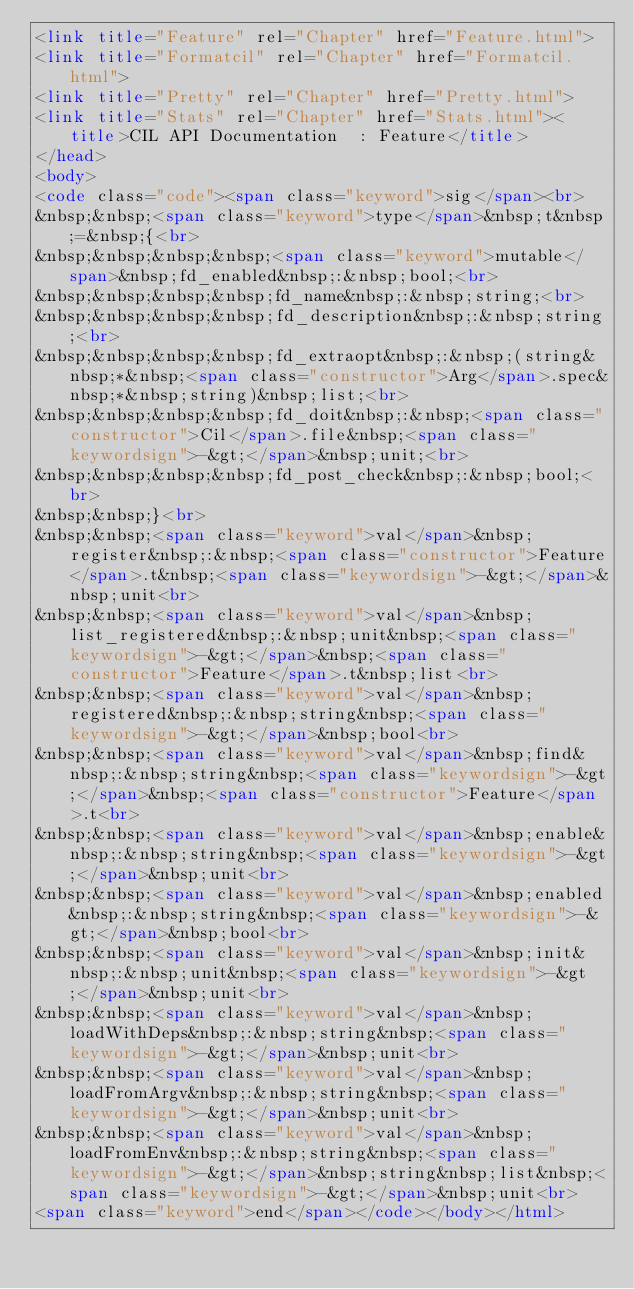Convert code to text. <code><loc_0><loc_0><loc_500><loc_500><_HTML_><link title="Feature" rel="Chapter" href="Feature.html">
<link title="Formatcil" rel="Chapter" href="Formatcil.html">
<link title="Pretty" rel="Chapter" href="Pretty.html">
<link title="Stats" rel="Chapter" href="Stats.html"><title>CIL API Documentation  : Feature</title>
</head>
<body>
<code class="code"><span class="keyword">sig</span><br>
&nbsp;&nbsp;<span class="keyword">type</span>&nbsp;t&nbsp;=&nbsp;{<br>
&nbsp;&nbsp;&nbsp;&nbsp;<span class="keyword">mutable</span>&nbsp;fd_enabled&nbsp;:&nbsp;bool;<br>
&nbsp;&nbsp;&nbsp;&nbsp;fd_name&nbsp;:&nbsp;string;<br>
&nbsp;&nbsp;&nbsp;&nbsp;fd_description&nbsp;:&nbsp;string;<br>
&nbsp;&nbsp;&nbsp;&nbsp;fd_extraopt&nbsp;:&nbsp;(string&nbsp;*&nbsp;<span class="constructor">Arg</span>.spec&nbsp;*&nbsp;string)&nbsp;list;<br>
&nbsp;&nbsp;&nbsp;&nbsp;fd_doit&nbsp;:&nbsp;<span class="constructor">Cil</span>.file&nbsp;<span class="keywordsign">-&gt;</span>&nbsp;unit;<br>
&nbsp;&nbsp;&nbsp;&nbsp;fd_post_check&nbsp;:&nbsp;bool;<br>
&nbsp;&nbsp;}<br>
&nbsp;&nbsp;<span class="keyword">val</span>&nbsp;register&nbsp;:&nbsp;<span class="constructor">Feature</span>.t&nbsp;<span class="keywordsign">-&gt;</span>&nbsp;unit<br>
&nbsp;&nbsp;<span class="keyword">val</span>&nbsp;list_registered&nbsp;:&nbsp;unit&nbsp;<span class="keywordsign">-&gt;</span>&nbsp;<span class="constructor">Feature</span>.t&nbsp;list<br>
&nbsp;&nbsp;<span class="keyword">val</span>&nbsp;registered&nbsp;:&nbsp;string&nbsp;<span class="keywordsign">-&gt;</span>&nbsp;bool<br>
&nbsp;&nbsp;<span class="keyword">val</span>&nbsp;find&nbsp;:&nbsp;string&nbsp;<span class="keywordsign">-&gt;</span>&nbsp;<span class="constructor">Feature</span>.t<br>
&nbsp;&nbsp;<span class="keyword">val</span>&nbsp;enable&nbsp;:&nbsp;string&nbsp;<span class="keywordsign">-&gt;</span>&nbsp;unit<br>
&nbsp;&nbsp;<span class="keyword">val</span>&nbsp;enabled&nbsp;:&nbsp;string&nbsp;<span class="keywordsign">-&gt;</span>&nbsp;bool<br>
&nbsp;&nbsp;<span class="keyword">val</span>&nbsp;init&nbsp;:&nbsp;unit&nbsp;<span class="keywordsign">-&gt;</span>&nbsp;unit<br>
&nbsp;&nbsp;<span class="keyword">val</span>&nbsp;loadWithDeps&nbsp;:&nbsp;string&nbsp;<span class="keywordsign">-&gt;</span>&nbsp;unit<br>
&nbsp;&nbsp;<span class="keyword">val</span>&nbsp;loadFromArgv&nbsp;:&nbsp;string&nbsp;<span class="keywordsign">-&gt;</span>&nbsp;unit<br>
&nbsp;&nbsp;<span class="keyword">val</span>&nbsp;loadFromEnv&nbsp;:&nbsp;string&nbsp;<span class="keywordsign">-&gt;</span>&nbsp;string&nbsp;list&nbsp;<span class="keywordsign">-&gt;</span>&nbsp;unit<br>
<span class="keyword">end</span></code></body></html></code> 